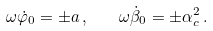<formula> <loc_0><loc_0><loc_500><loc_500>\omega \dot { \varphi } _ { 0 } = \pm a \, , \quad \omega \dot { \beta } _ { 0 } = \pm \alpha _ { c } ^ { 2 } \, .</formula> 